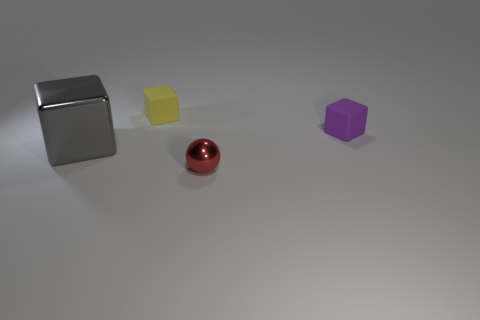Subtract all big gray metal blocks. How many blocks are left? 2 Add 4 small cyan rubber spheres. How many objects exist? 8 Subtract 0 green cylinders. How many objects are left? 4 Subtract all balls. How many objects are left? 3 Subtract 1 balls. How many balls are left? 0 Subtract all purple balls. Subtract all yellow cubes. How many balls are left? 1 Subtract all blue cylinders. How many gray cubes are left? 1 Subtract all matte things. Subtract all gray metal things. How many objects are left? 1 Add 4 gray objects. How many gray objects are left? 5 Add 3 small cyan shiny cylinders. How many small cyan shiny cylinders exist? 3 